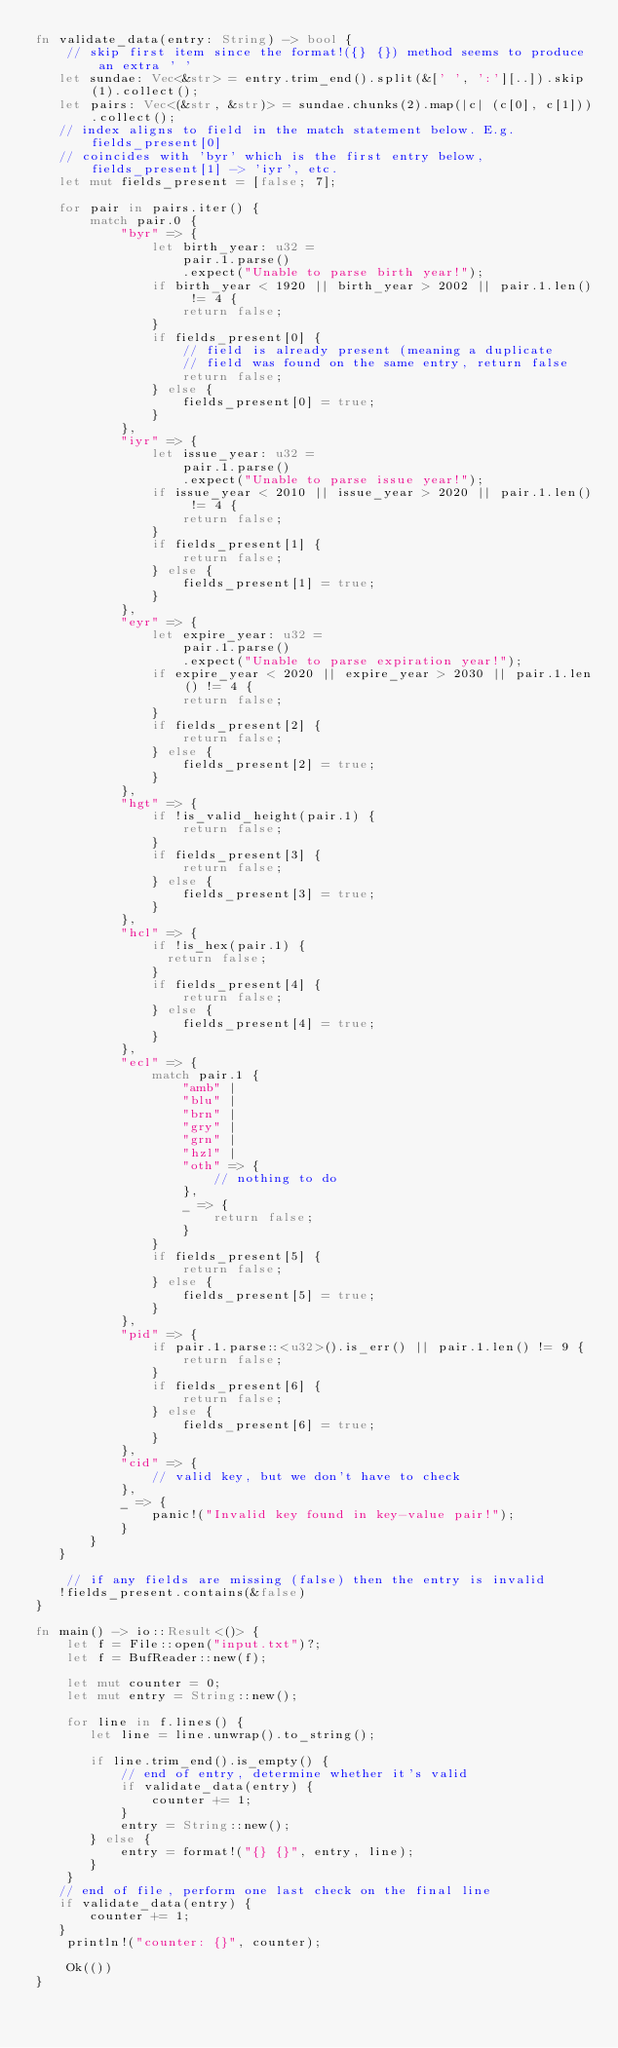Convert code to text. <code><loc_0><loc_0><loc_500><loc_500><_Rust_>fn validate_data(entry: String) -> bool {
    // skip first item since the format!({} {}) method seems to produce an extra ' '
   let sundae: Vec<&str> = entry.trim_end().split(&[' ', ':'][..]).skip(1).collect();
   let pairs: Vec<(&str, &str)> = sundae.chunks(2).map(|c| (c[0], c[1])).collect();
   // index aligns to field in the match statement below. E.g. fields_present[0]
   // coincides with 'byr' which is the first entry below, fields_present[1] -> 'iyr', etc.
   let mut fields_present = [false; 7];

   for pair in pairs.iter() {
       match pair.0 {
           "byr" => {
               let birth_year: u32 =
                   pair.1.parse()
                   .expect("Unable to parse birth year!");
               if birth_year < 1920 || birth_year > 2002 || pair.1.len() != 4 {
                   return false;
               }
               if fields_present[0] {
                   // field is already present (meaning a duplicate
                   // field was found on the same entry, return false
                   return false;
               } else {
                   fields_present[0] = true;
               }
           },
           "iyr" => {
               let issue_year: u32 =
                   pair.1.parse()
                   .expect("Unable to parse issue year!");
               if issue_year < 2010 || issue_year > 2020 || pair.1.len() != 4 {
                   return false;
               }
               if fields_present[1] {
                   return false;
               } else {
                   fields_present[1] = true;
               }
           },
           "eyr" => {
               let expire_year: u32 =
                   pair.1.parse()
                   .expect("Unable to parse expiration year!");
               if expire_year < 2020 || expire_year > 2030 || pair.1.len() != 4 {
                   return false;
               }
               if fields_present[2] {
                   return false;
               } else {
                   fields_present[2] = true;
               }
           },
           "hgt" => {
               if !is_valid_height(pair.1) {
                   return false;
               }
               if fields_present[3] {
                   return false;
               } else {
                   fields_present[3] = true;
               }
           },
           "hcl" => {
               if !is_hex(pair.1) {
                 return false; 
               }
               if fields_present[4] {
                   return false;
               } else {
                   fields_present[4] = true;
               }
           },
           "ecl" => {
               match pair.1 {
                   "amb" |
                   "blu" |
                   "brn" |
                   "gry" |
                   "grn" |
                   "hzl" |
                   "oth" => {
                       // nothing to do
                   },
                   _ => {
                       return false;
                   }
               }
               if fields_present[5] {
                   return false;
               } else {
                   fields_present[5] = true;
               }
           },
           "pid" => {
               if pair.1.parse::<u32>().is_err() || pair.1.len() != 9 {
                   return false;
               }
               if fields_present[6] {
                   return false;
               } else {
                   fields_present[6] = true;
               }
           },
           "cid" => {
               // valid key, but we don't have to check
           },
           _ => {
               panic!("Invalid key found in key-value pair!");
           }
       }
   }

    // if any fields are missing (false) then the entry is invalid
   !fields_present.contains(&false)
}

fn main() -> io::Result<()> {
    let f = File::open("input.txt")?;
    let f = BufReader::new(f);

    let mut counter = 0;
    let mut entry = String::new();

    for line in f.lines() {
       let line = line.unwrap().to_string();

       if line.trim_end().is_empty() {
           // end of entry, determine whether it's valid
           if validate_data(entry) {
               counter += 1;
           }
           entry = String::new();
       } else {
           entry = format!("{} {}", entry, line);
       }
    }
   // end of file, perform one last check on the final line
   if validate_data(entry) {
       counter += 1;
   }
    println!("counter: {}", counter);

    Ok(())
}
</code> 